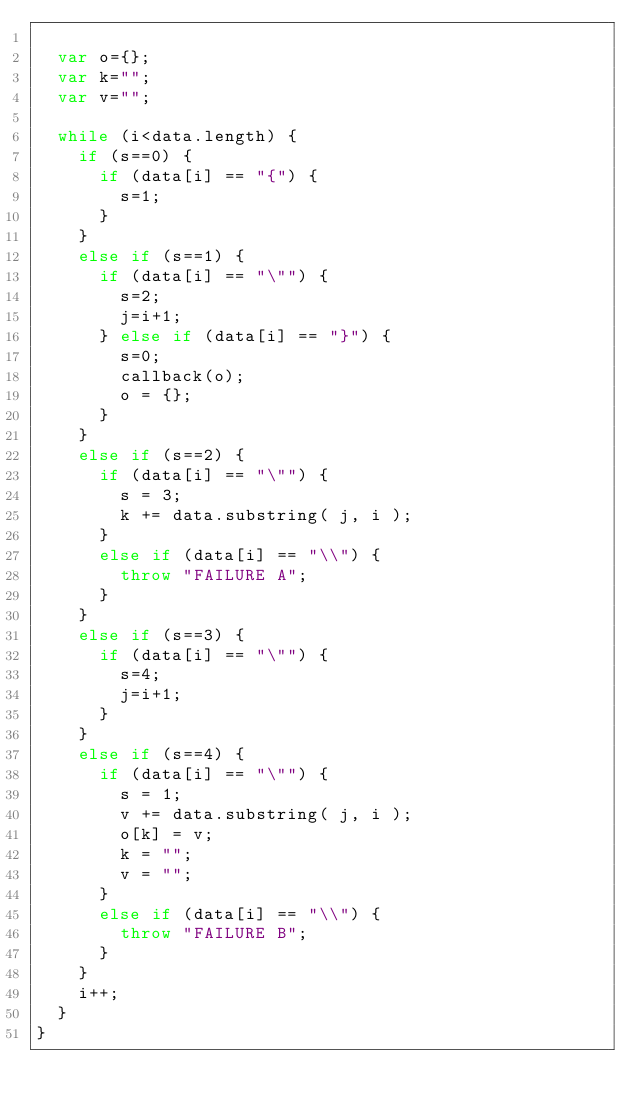<code> <loc_0><loc_0><loc_500><loc_500><_JavaScript_>	
	var o={};
	var k="";
	var v="";
	
	while (i<data.length) {
		if (s==0) {
			if (data[i] == "{") {
				s=1;
			}
		}
		else if (s==1) {
			if (data[i] == "\"") {
				s=2;
				j=i+1;
			} else if (data[i] == "}") {
				s=0;
				callback(o);
				o = {};
			}
		}
		else if (s==2) {
			if (data[i] == "\"") {
				s = 3;
				k += data.substring( j, i );
			}
			else if (data[i] == "\\") {
				throw "FAILURE A";	
			}
		}
		else if (s==3) {
			if (data[i] == "\"") {
				s=4;
				j=i+1;
			}
		}
		else if (s==4) {
			if (data[i] == "\"") {
				s = 1;
				v += data.substring( j, i );
				o[k] = v;
				k = "";
				v = "";
			}
			else if (data[i] == "\\") {
				throw "FAILURE B";	
			}
		}
		i++;
	}
}</code> 